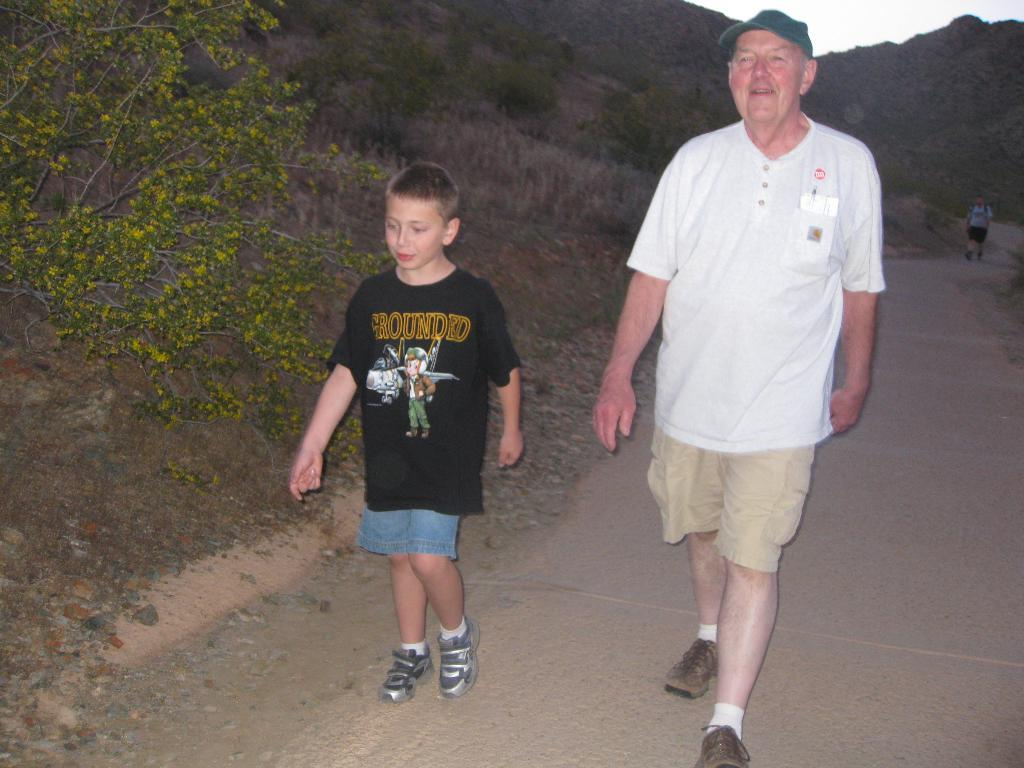How many people are in the image? There are three persons in the image. What are the persons doing in the image? The persons are walking on the road. What can be seen in the background of the image? There is a mountain in the background. What is visible at the top of the image? The sky is visible at the top of the image. What is the main pathway in the image? There is a road in the image. Can you see any stars in the image? There are no stars visible in the image; only the sky is visible at the top. Is there any magic happening in the image? There is no magic present in the image; it shows three persons walking on the road. 